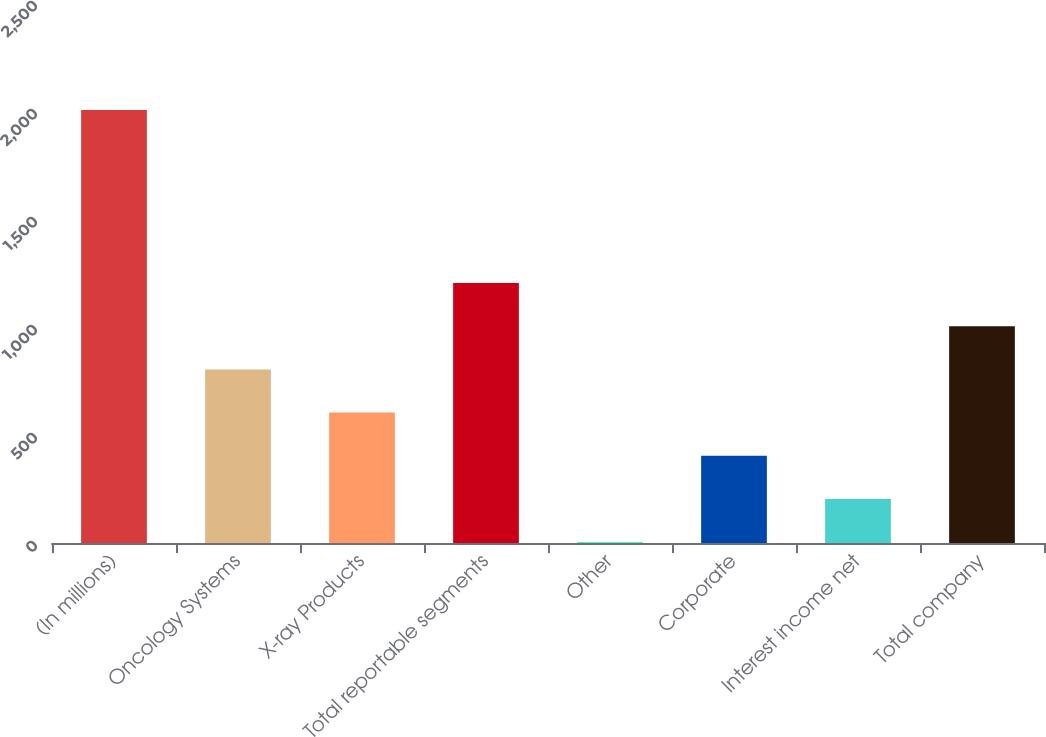Convert chart. <chart><loc_0><loc_0><loc_500><loc_500><bar_chart><fcel>(In millions)<fcel>Oncology Systems<fcel>X-ray Products<fcel>Total reportable segments<fcel>Other<fcel>Corporate<fcel>Interest income net<fcel>Total company<nl><fcel>2005<fcel>803.8<fcel>603.6<fcel>1204.2<fcel>3<fcel>403.4<fcel>203.2<fcel>1004<nl></chart> 